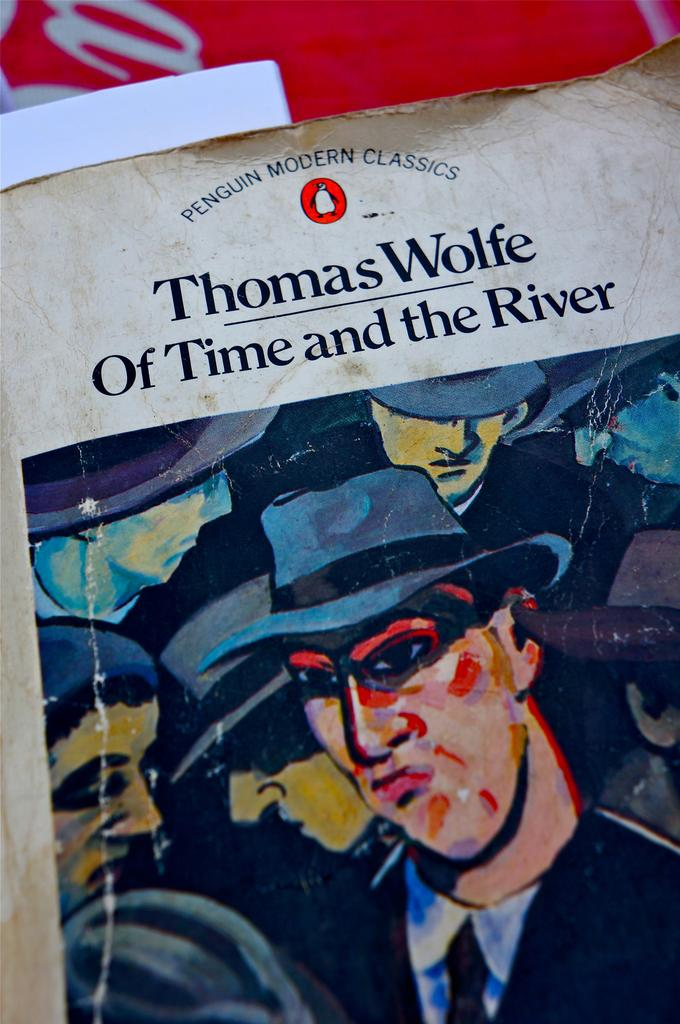What is the main subject of the image? The image contains a painting. What can be seen in the painting? The painting depicts persons wearing black-colored dresses and hats. What is the medium of the painting? The painting is on paper. What color is used for the text in the image? There is something written in black color in the image. Can you see any wilderness or group of animals in the image? No, there is no wilderness or group of animals present in the image. The image contains a painting of persons wearing black-colored dresses and hats, with text written in black color. 